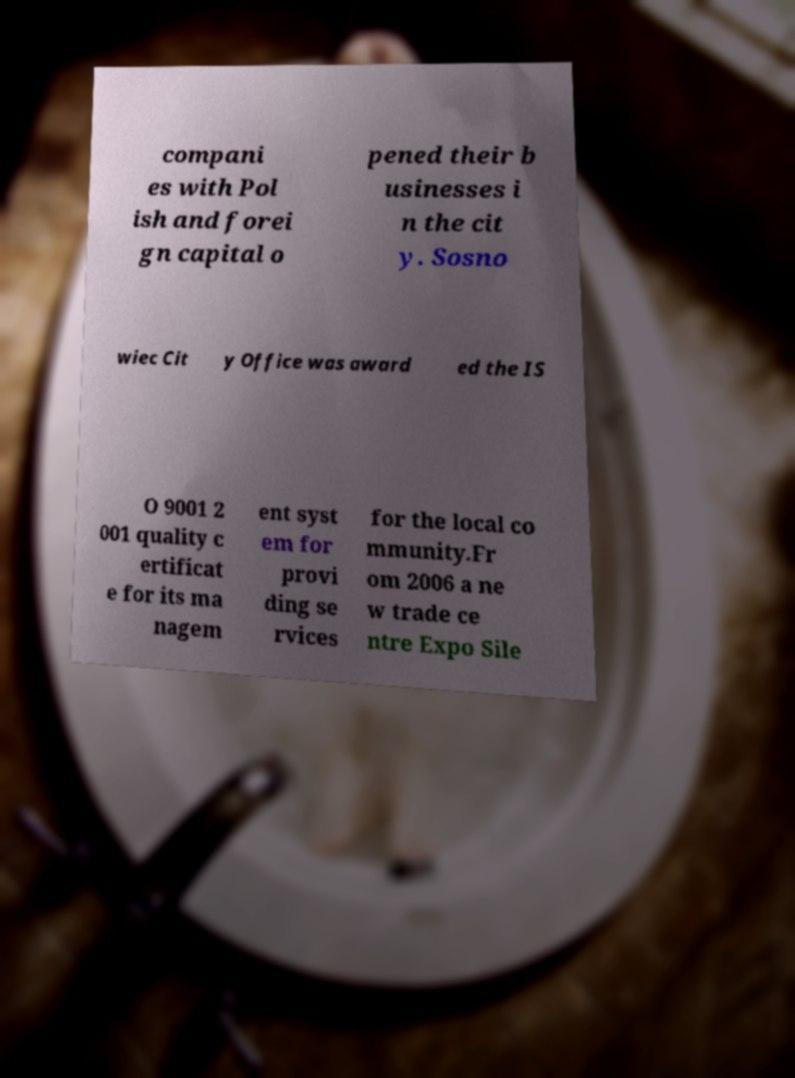There's text embedded in this image that I need extracted. Can you transcribe it verbatim? compani es with Pol ish and forei gn capital o pened their b usinesses i n the cit y. Sosno wiec Cit y Office was award ed the IS O 9001 2 001 quality c ertificat e for its ma nagem ent syst em for provi ding se rvices for the local co mmunity.Fr om 2006 a ne w trade ce ntre Expo Sile 